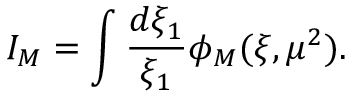Convert formula to latex. <formula><loc_0><loc_0><loc_500><loc_500>I _ { M } = \int { \frac { d \xi _ { 1 } } { \xi _ { 1 } } } \phi _ { M } ( \xi , \mu ^ { 2 } ) .</formula> 